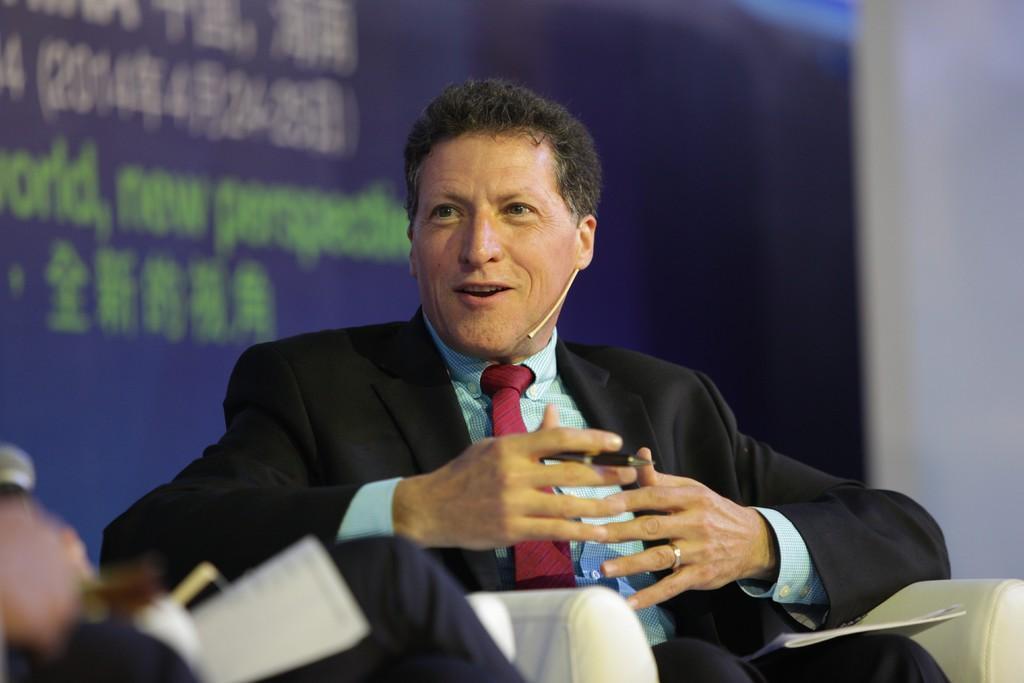Could you give a brief overview of what you see in this image? In this image the person is sitting on the chair and talking something and wearing blue shirt,red tie and black coat. 